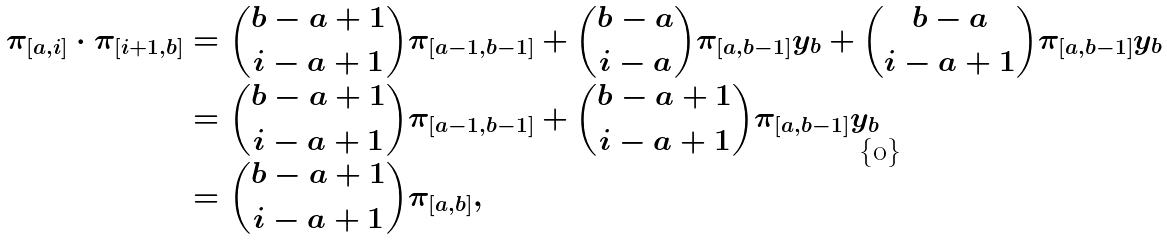Convert formula to latex. <formula><loc_0><loc_0><loc_500><loc_500>\pi _ { [ a , i ] } \cdot \pi _ { [ i + 1 , b ] } & = \binom { b - a + 1 } { i - a + 1 } \pi _ { [ a - 1 , b - 1 ] } + \binom { b - a } { i - a } \pi _ { [ a , b - 1 ] } y _ { b } + \binom { b - a } { i - a + 1 } \pi _ { [ a , b - 1 ] } y _ { b } \\ & = \binom { b - a + 1 } { i - a + 1 } \pi _ { [ a - 1 , b - 1 ] } + \binom { b - a + 1 } { i - a + 1 } \pi _ { [ a , b - 1 ] } y _ { b } \\ & = \binom { b - a + 1 } { i - a + 1 } \pi _ { [ a , b ] } ,</formula> 